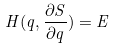<formula> <loc_0><loc_0><loc_500><loc_500>H ( q , \frac { \partial S } { \partial q } ) = E</formula> 